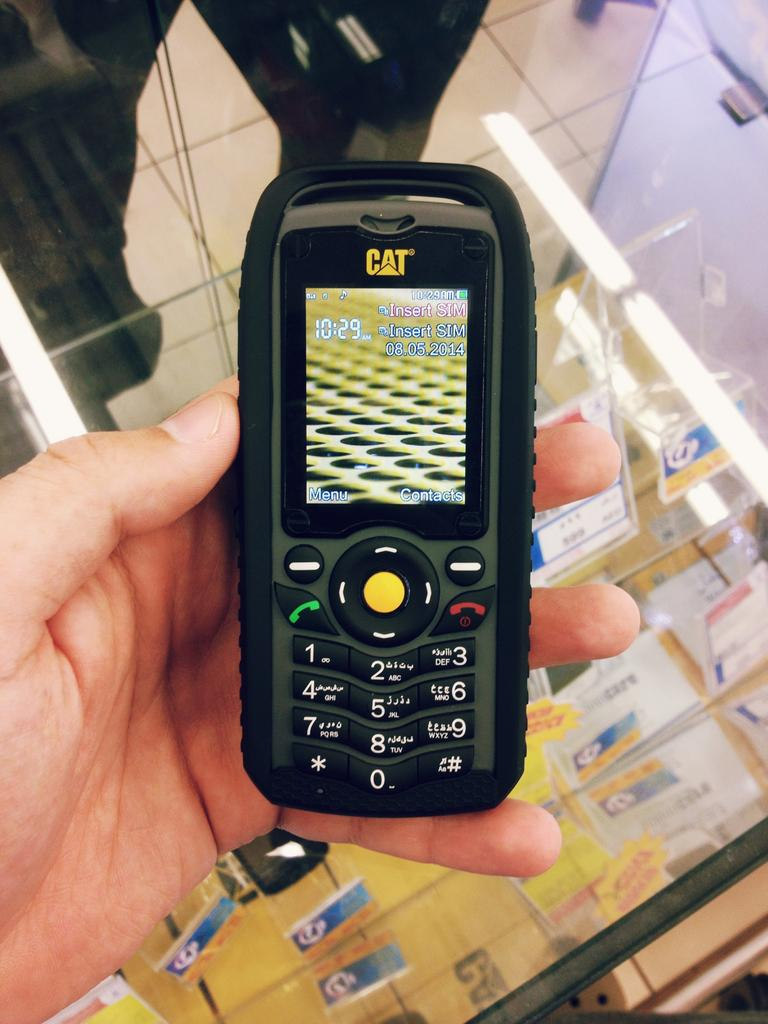<image>
Create a compact narrative representing the image presented. A black CAT phone being held in someones hand. 